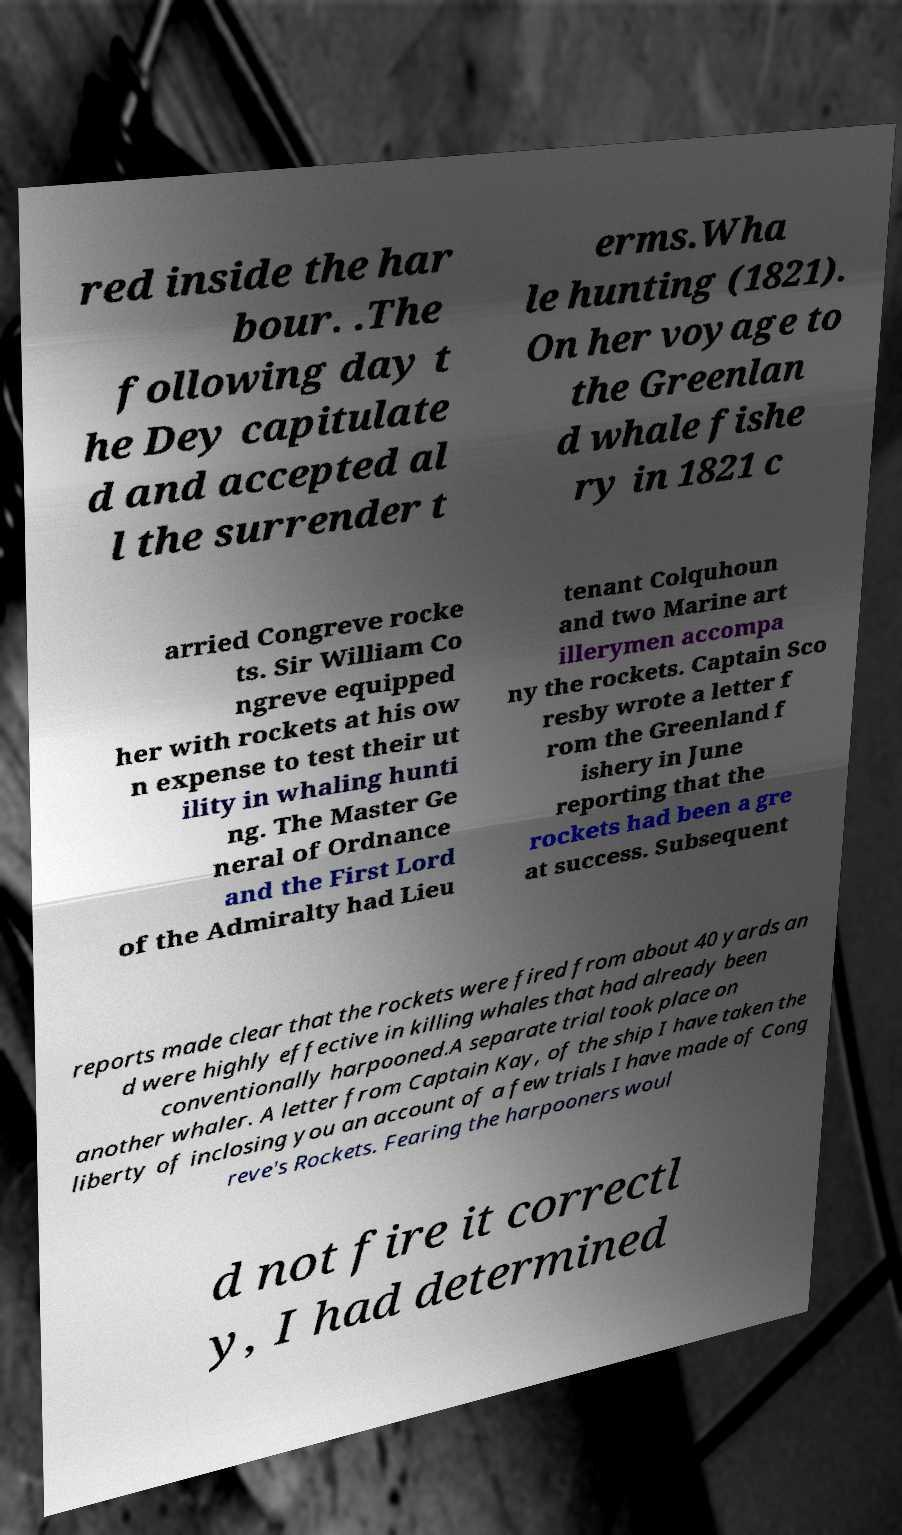Could you extract and type out the text from this image? red inside the har bour. .The following day t he Dey capitulate d and accepted al l the surrender t erms.Wha le hunting (1821). On her voyage to the Greenlan d whale fishe ry in 1821 c arried Congreve rocke ts. Sir William Co ngreve equipped her with rockets at his ow n expense to test their ut ility in whaling hunti ng. The Master Ge neral of Ordnance and the First Lord of the Admiralty had Lieu tenant Colquhoun and two Marine art illerymen accompa ny the rockets. Captain Sco resby wrote a letter f rom the Greenland f ishery in June reporting that the rockets had been a gre at success. Subsequent reports made clear that the rockets were fired from about 40 yards an d were highly effective in killing whales that had already been conventionally harpooned.A separate trial took place on another whaler. A letter from Captain Kay, of the ship I have taken the liberty of inclosing you an account of a few trials I have made of Cong reve's Rockets. Fearing the harpooners woul d not fire it correctl y, I had determined 